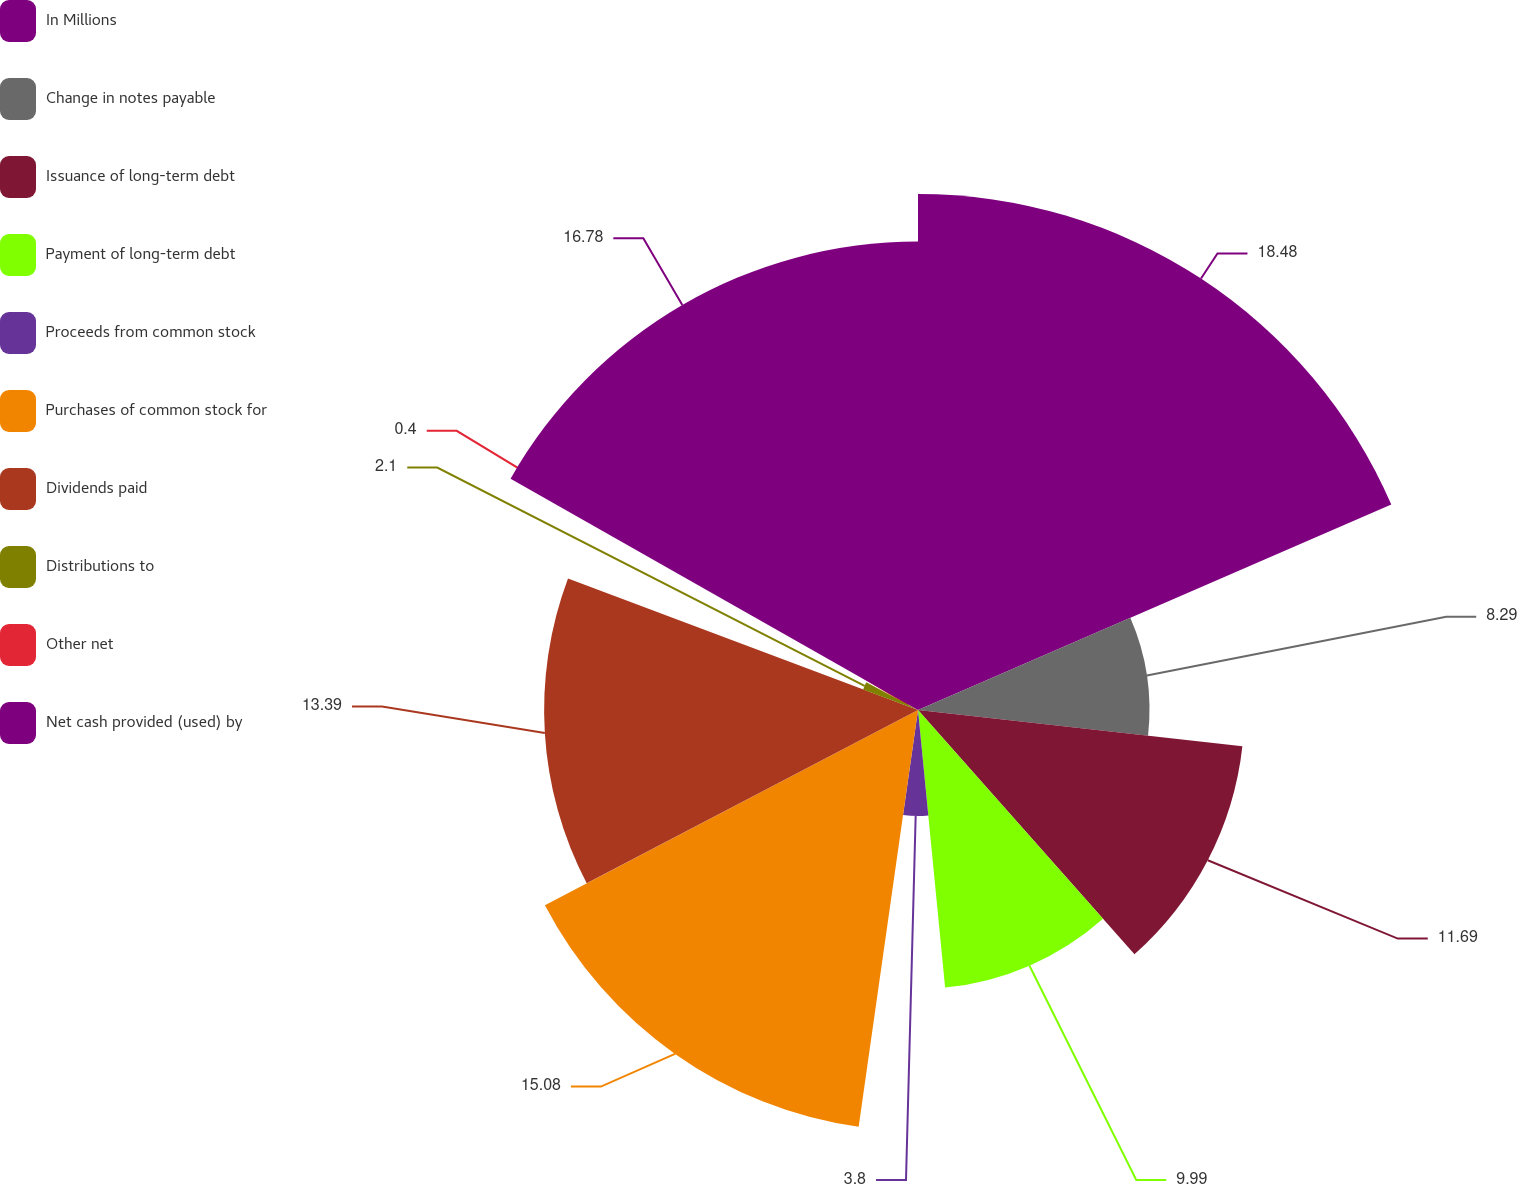Convert chart to OTSL. <chart><loc_0><loc_0><loc_500><loc_500><pie_chart><fcel>In Millions<fcel>Change in notes payable<fcel>Issuance of long-term debt<fcel>Payment of long-term debt<fcel>Proceeds from common stock<fcel>Purchases of common stock for<fcel>Dividends paid<fcel>Distributions to<fcel>Other net<fcel>Net cash provided (used) by<nl><fcel>18.48%<fcel>8.29%<fcel>11.69%<fcel>9.99%<fcel>3.8%<fcel>15.08%<fcel>13.39%<fcel>2.1%<fcel>0.4%<fcel>16.78%<nl></chart> 